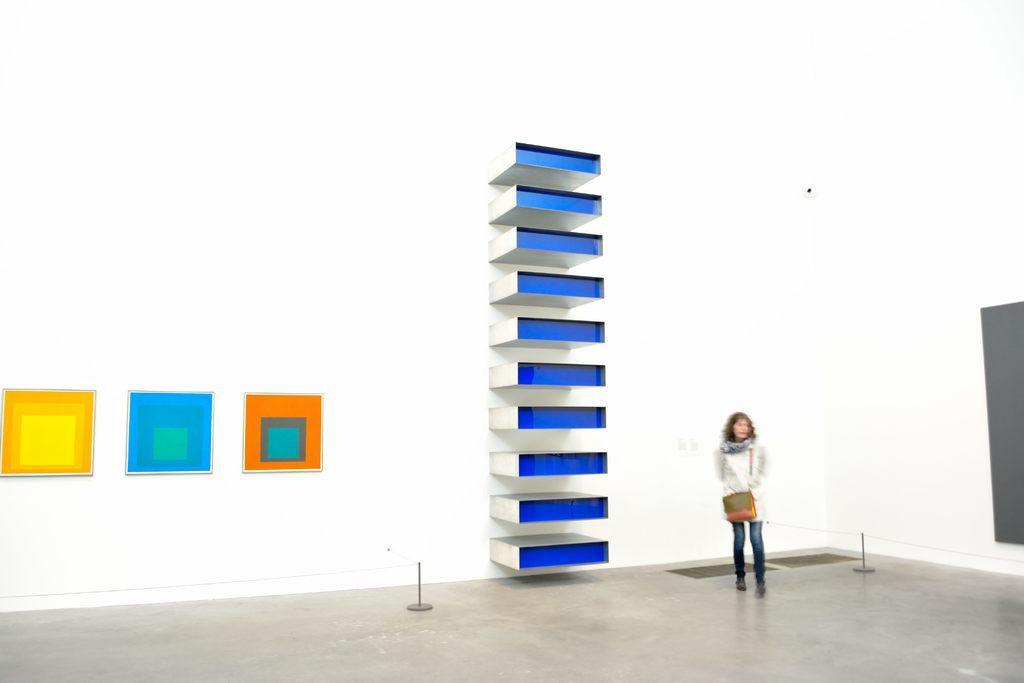Describe this image in one or two sentences. In this image there is a lady standing on a floor, in the background there is a wall and there are blocks. 